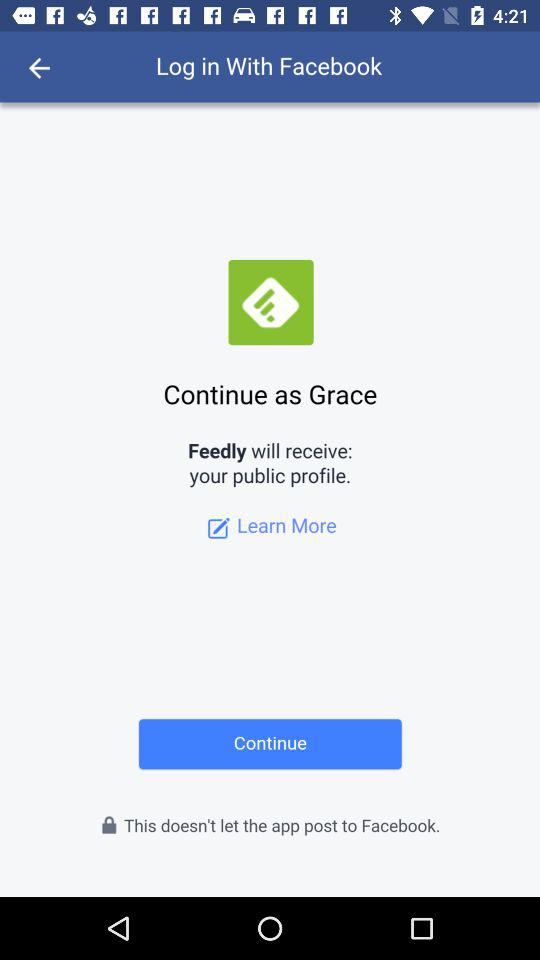What application will receive the public profile? The application is "Feedly". 